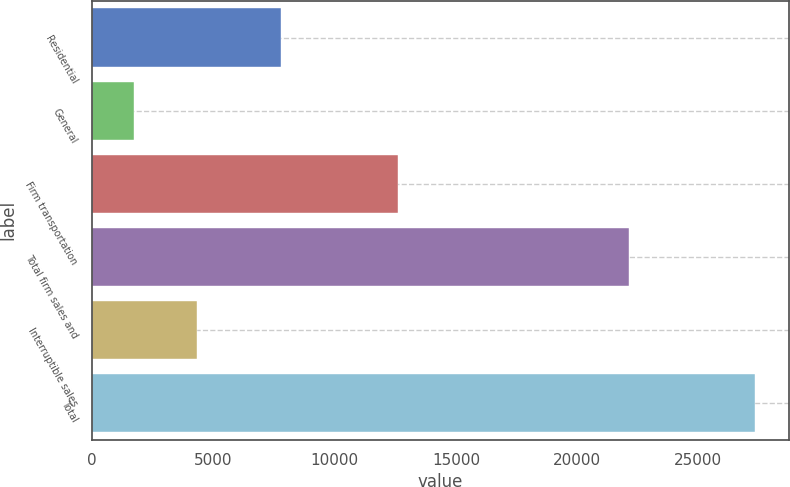Convert chart to OTSL. <chart><loc_0><loc_0><loc_500><loc_500><bar_chart><fcel>Residential<fcel>General<fcel>Firm transportation<fcel>Total firm sales and<fcel>Interruptible sales<fcel>Total<nl><fcel>7786<fcel>1743<fcel>12592<fcel>22121<fcel>4303.9<fcel>27352<nl></chart> 